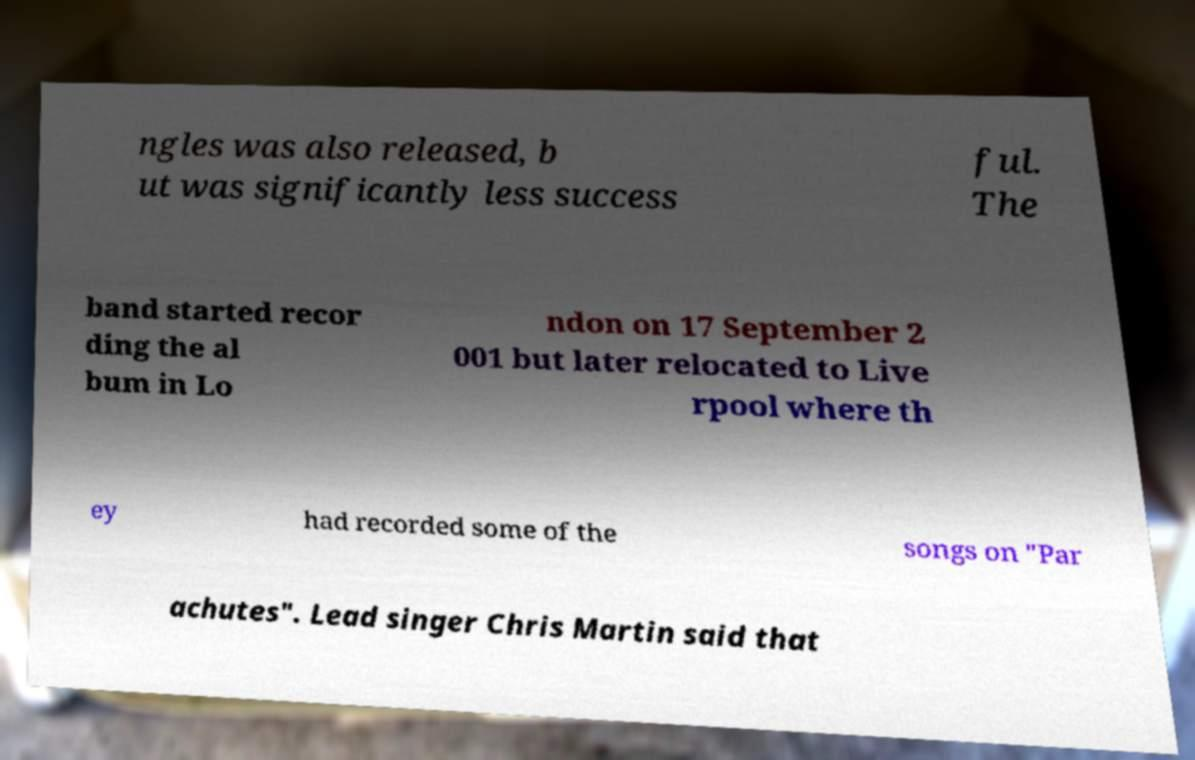Please read and relay the text visible in this image. What does it say? ngles was also released, b ut was significantly less success ful. The band started recor ding the al bum in Lo ndon on 17 September 2 001 but later relocated to Live rpool where th ey had recorded some of the songs on "Par achutes". Lead singer Chris Martin said that 